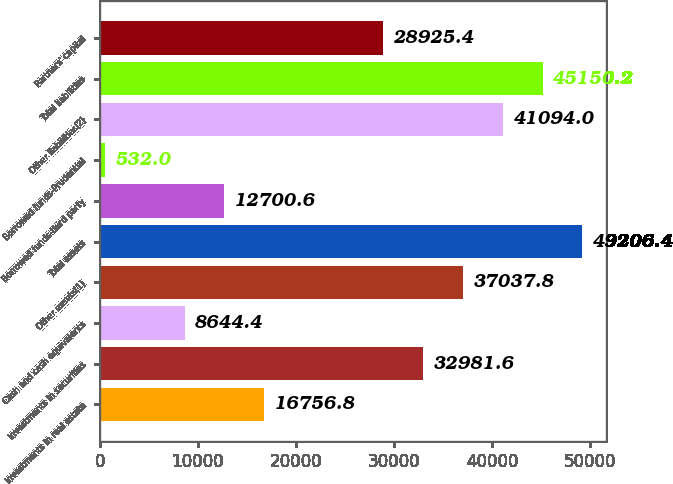<chart> <loc_0><loc_0><loc_500><loc_500><bar_chart><fcel>Investments in real estate<fcel>Investments in securities<fcel>Cash and cash equivalents<fcel>Other assets(1)<fcel>Total assets<fcel>Borrowed funds-third party<fcel>Borrowed funds-Prudential<fcel>Other liabilities(2)<fcel>Total liabilities<fcel>Partners' capital<nl><fcel>16756.8<fcel>32981.6<fcel>8644.4<fcel>37037.8<fcel>49206.4<fcel>12700.6<fcel>532<fcel>41094<fcel>45150.2<fcel>28925.4<nl></chart> 